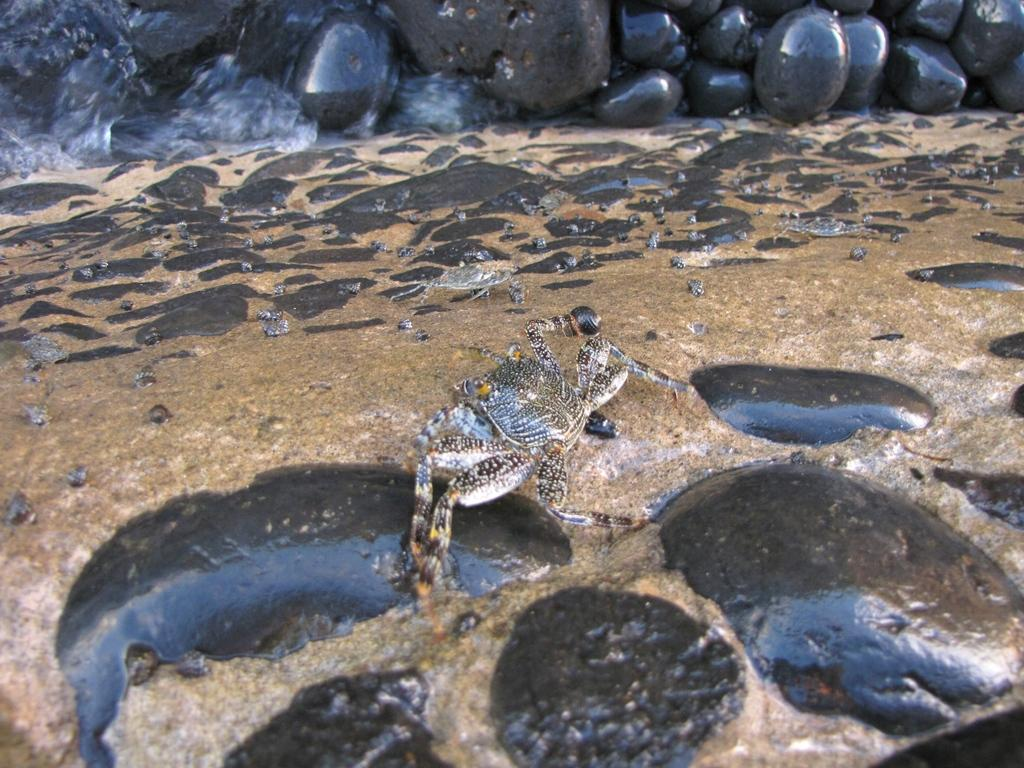What animal can be seen in the image? There is a crab in the image. What is the crab doing in the image? The crab is walking in the water. Where is the water located in the image? The water is on the ground. What else can be found on the ground in the image? There are rocks on the ground. What can be seen in the background of the image? In the background, there are rocks arranged. Can you tell me how many cattle are present in the image? There are no cattle present in the image; it features a crab walking in the water. Is there a woman in the image interacting with the crab? There is no woman present in the image; it only shows a crab walking in the water. 